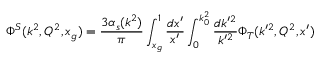Convert formula to latex. <formula><loc_0><loc_0><loc_500><loc_500>\Phi ^ { S } ( k ^ { 2 } , Q ^ { 2 } , x _ { g } ) = { \frac { 3 \alpha _ { s } ( k ^ { 2 } ) } { \pi } } \int _ { x _ { g } } ^ { 1 } { \frac { d x ^ { \prime } } { x ^ { \prime } } } \int _ { 0 } ^ { k _ { 0 } ^ { 2 } } { \frac { d k ^ { \prime 2 } } { k ^ { \prime 2 } } } \Phi _ { T } ( k ^ { \prime 2 } , Q ^ { 2 } , x ^ { \prime } )</formula> 